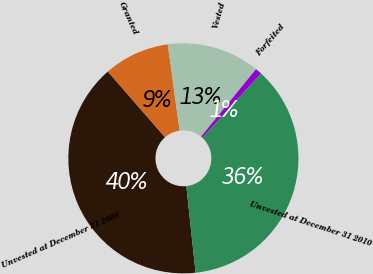Convert chart to OTSL. <chart><loc_0><loc_0><loc_500><loc_500><pie_chart><fcel>Unvested at December 31 2009<fcel>Granted<fcel>Vested<fcel>Forfeited<fcel>Unvested at December 31 2010<nl><fcel>40.29%<fcel>9.24%<fcel>13.04%<fcel>0.93%<fcel>36.5%<nl></chart> 